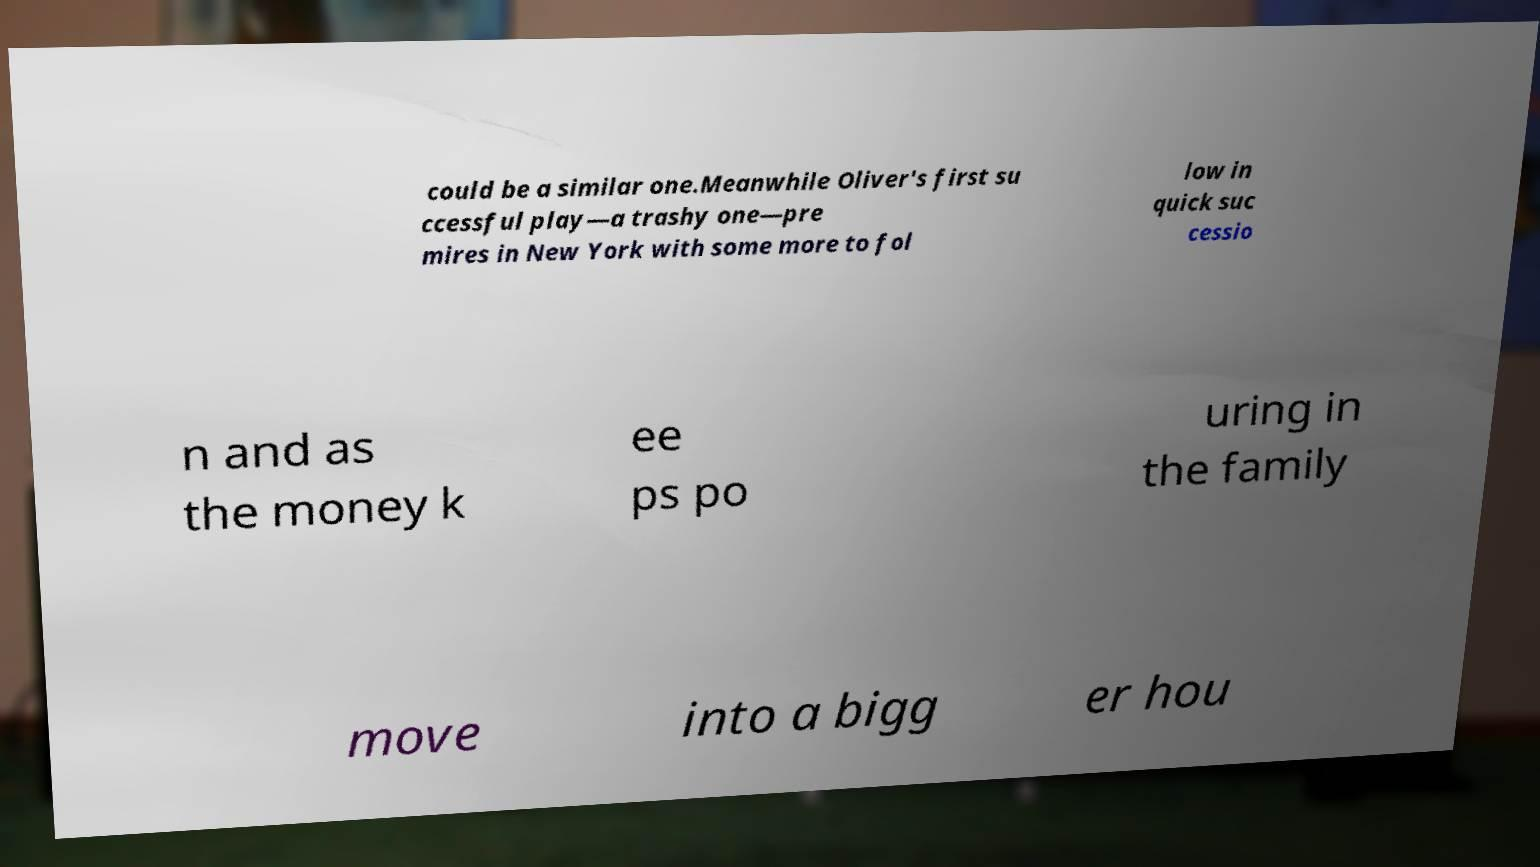What messages or text are displayed in this image? I need them in a readable, typed format. could be a similar one.Meanwhile Oliver's first su ccessful play—a trashy one—pre mires in New York with some more to fol low in quick suc cessio n and as the money k ee ps po uring in the family move into a bigg er hou 